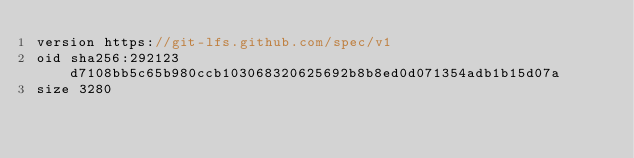Convert code to text. <code><loc_0><loc_0><loc_500><loc_500><_C++_>version https://git-lfs.github.com/spec/v1
oid sha256:292123d7108bb5c65b980ccb103068320625692b8b8ed0d071354adb1b15d07a
size 3280
</code> 